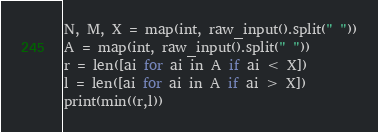<code> <loc_0><loc_0><loc_500><loc_500><_Python_>N, M, X = map(int, raw_input().split(" "))
A = map(int, raw_input().split(" "))
r = len([ai for ai in A if ai < X])
l = len([ai for ai in A if ai > X])
print(min((r,l))</code> 